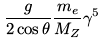<formula> <loc_0><loc_0><loc_500><loc_500>\frac { g } { 2 \cos \theta } \frac { m _ { e } } { M _ { Z } } \gamma ^ { 5 }</formula> 